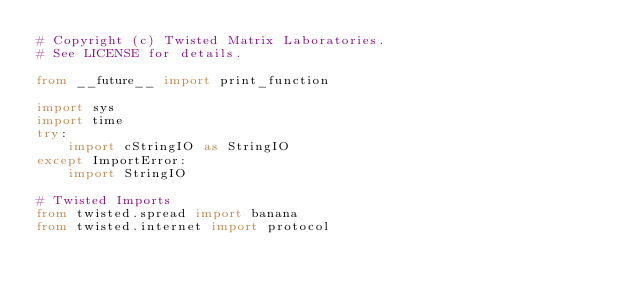<code> <loc_0><loc_0><loc_500><loc_500><_Python_># Copyright (c) Twisted Matrix Laboratories.
# See LICENSE for details.

from __future__ import print_function

import sys
import time
try:
    import cStringIO as StringIO
except ImportError:
    import StringIO
    
# Twisted Imports
from twisted.spread import banana
from twisted.internet import protocol
</code> 